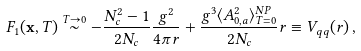<formula> <loc_0><loc_0><loc_500><loc_500>F _ { 1 } ( { \mathbf x } , T ) \stackrel { T \rightarrow 0 } \sim - \frac { N _ { c } ^ { 2 } - 1 } { 2 N _ { c } } \frac { g ^ { 2 } } { 4 \pi r } + \frac { g ^ { 3 } \langle A _ { 0 , a } ^ { 2 } \rangle _ { T = 0 } ^ { N P } } { 2 N _ { c } } r \equiv V _ { q q } ( r ) \, ,</formula> 